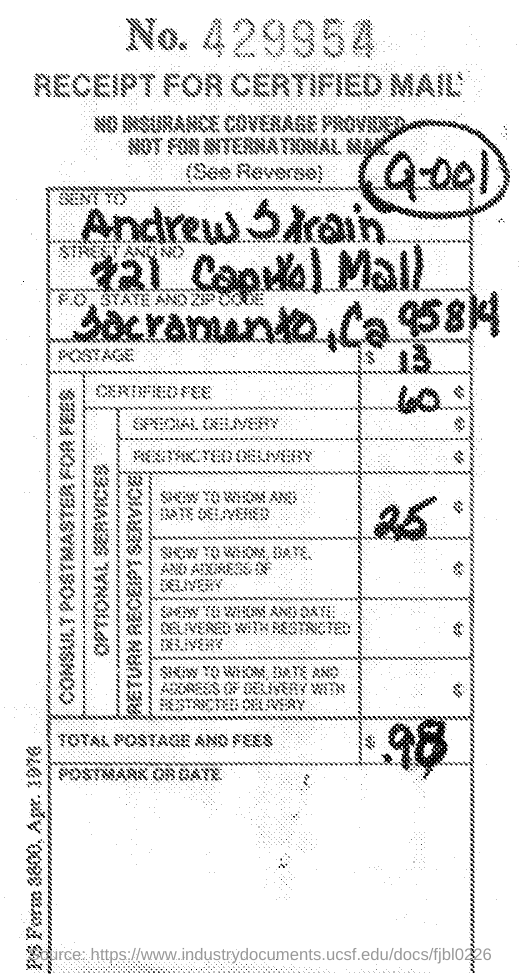What is the receipt no ?
Provide a succinct answer. 429954. What is the total postage and fees
Ensure brevity in your answer.  $98. 